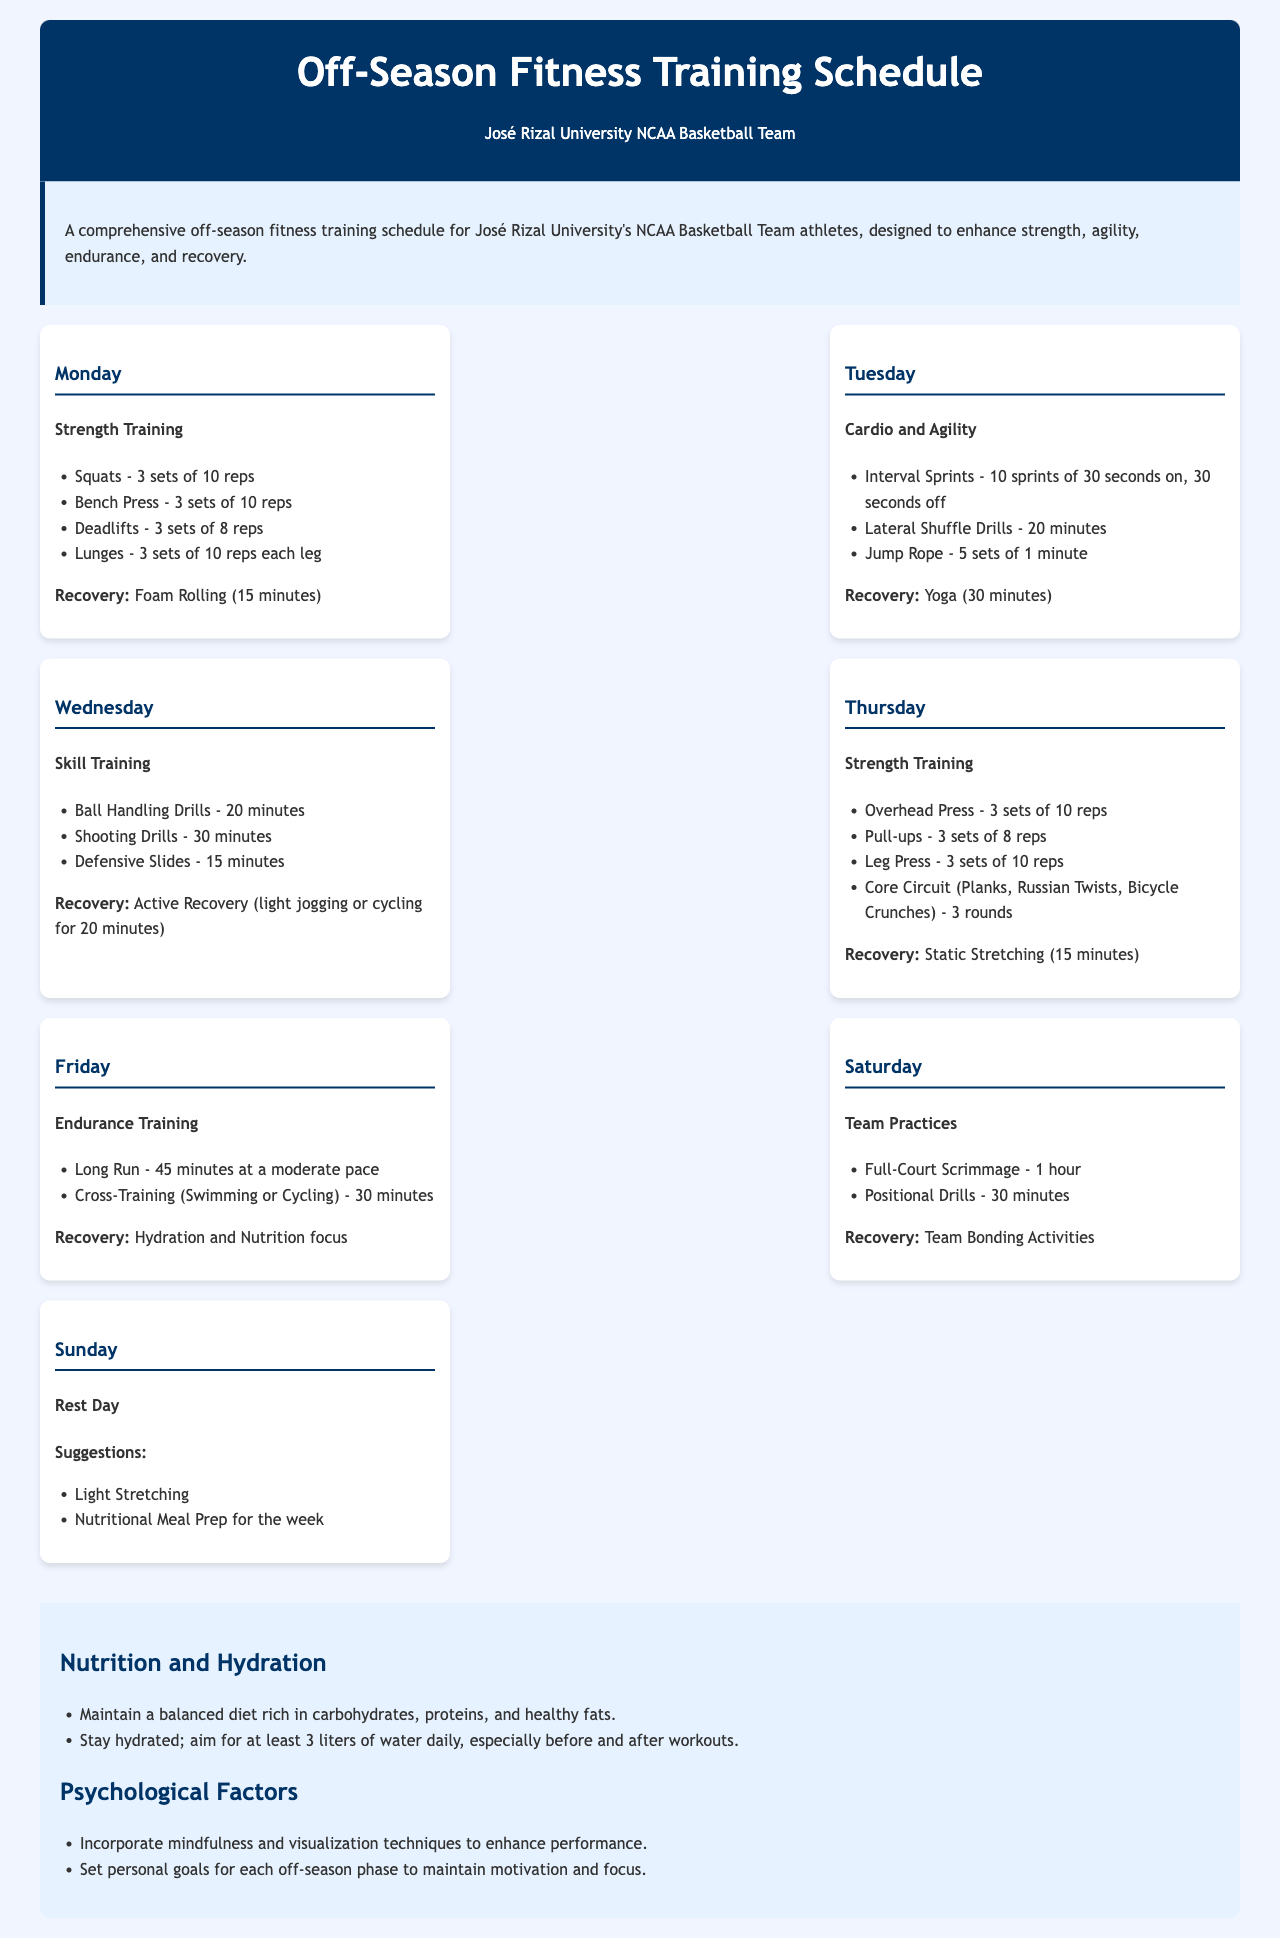What is the main purpose of the fitness training schedule? The purpose outlined in the document is to enhance strength, agility, endurance, and recovery for the athletes of the JRU NCAA Basketball Team.
Answer: Enhance strength, agility, endurance, and recovery How many sets are designated for Squats on Monday? The document specifies that Squats are to be performed for 3 sets of 10 reps.
Answer: 3 sets What type of training is scheduled for Wednesday? The document lists Skill Training as the focus for Wednesday's workout routine.
Answer: Skill Training What is the duration of the active recovery recommended on Wednesday? The document mentions that active recovery should consist of light jogging or cycling for 20 minutes.
Answer: 20 minutes Which day is scheduled for a Rest Day? According to the document, Sunday is designated as the Rest Day.
Answer: Sunday How many minutes of yoga are suggested on Tuesday? The document states that 30 minutes of Yoga are recommended for recovery on Tuesday.
Answer: 30 minutes What activity takes place on Friday besides long runs? The document indicates that Cross-Training (Swimming or Cycling) for 30 minutes is also scheduled.
Answer: Cross-Training (Swimming or Cycling) What is the focus of nutrition outlined in the additional information section? The document stresses the importance of maintaining a balanced diet and staying hydrated after workouts.
Answer: Balanced diet rich in carbohydrates, proteins, and healthy fats 